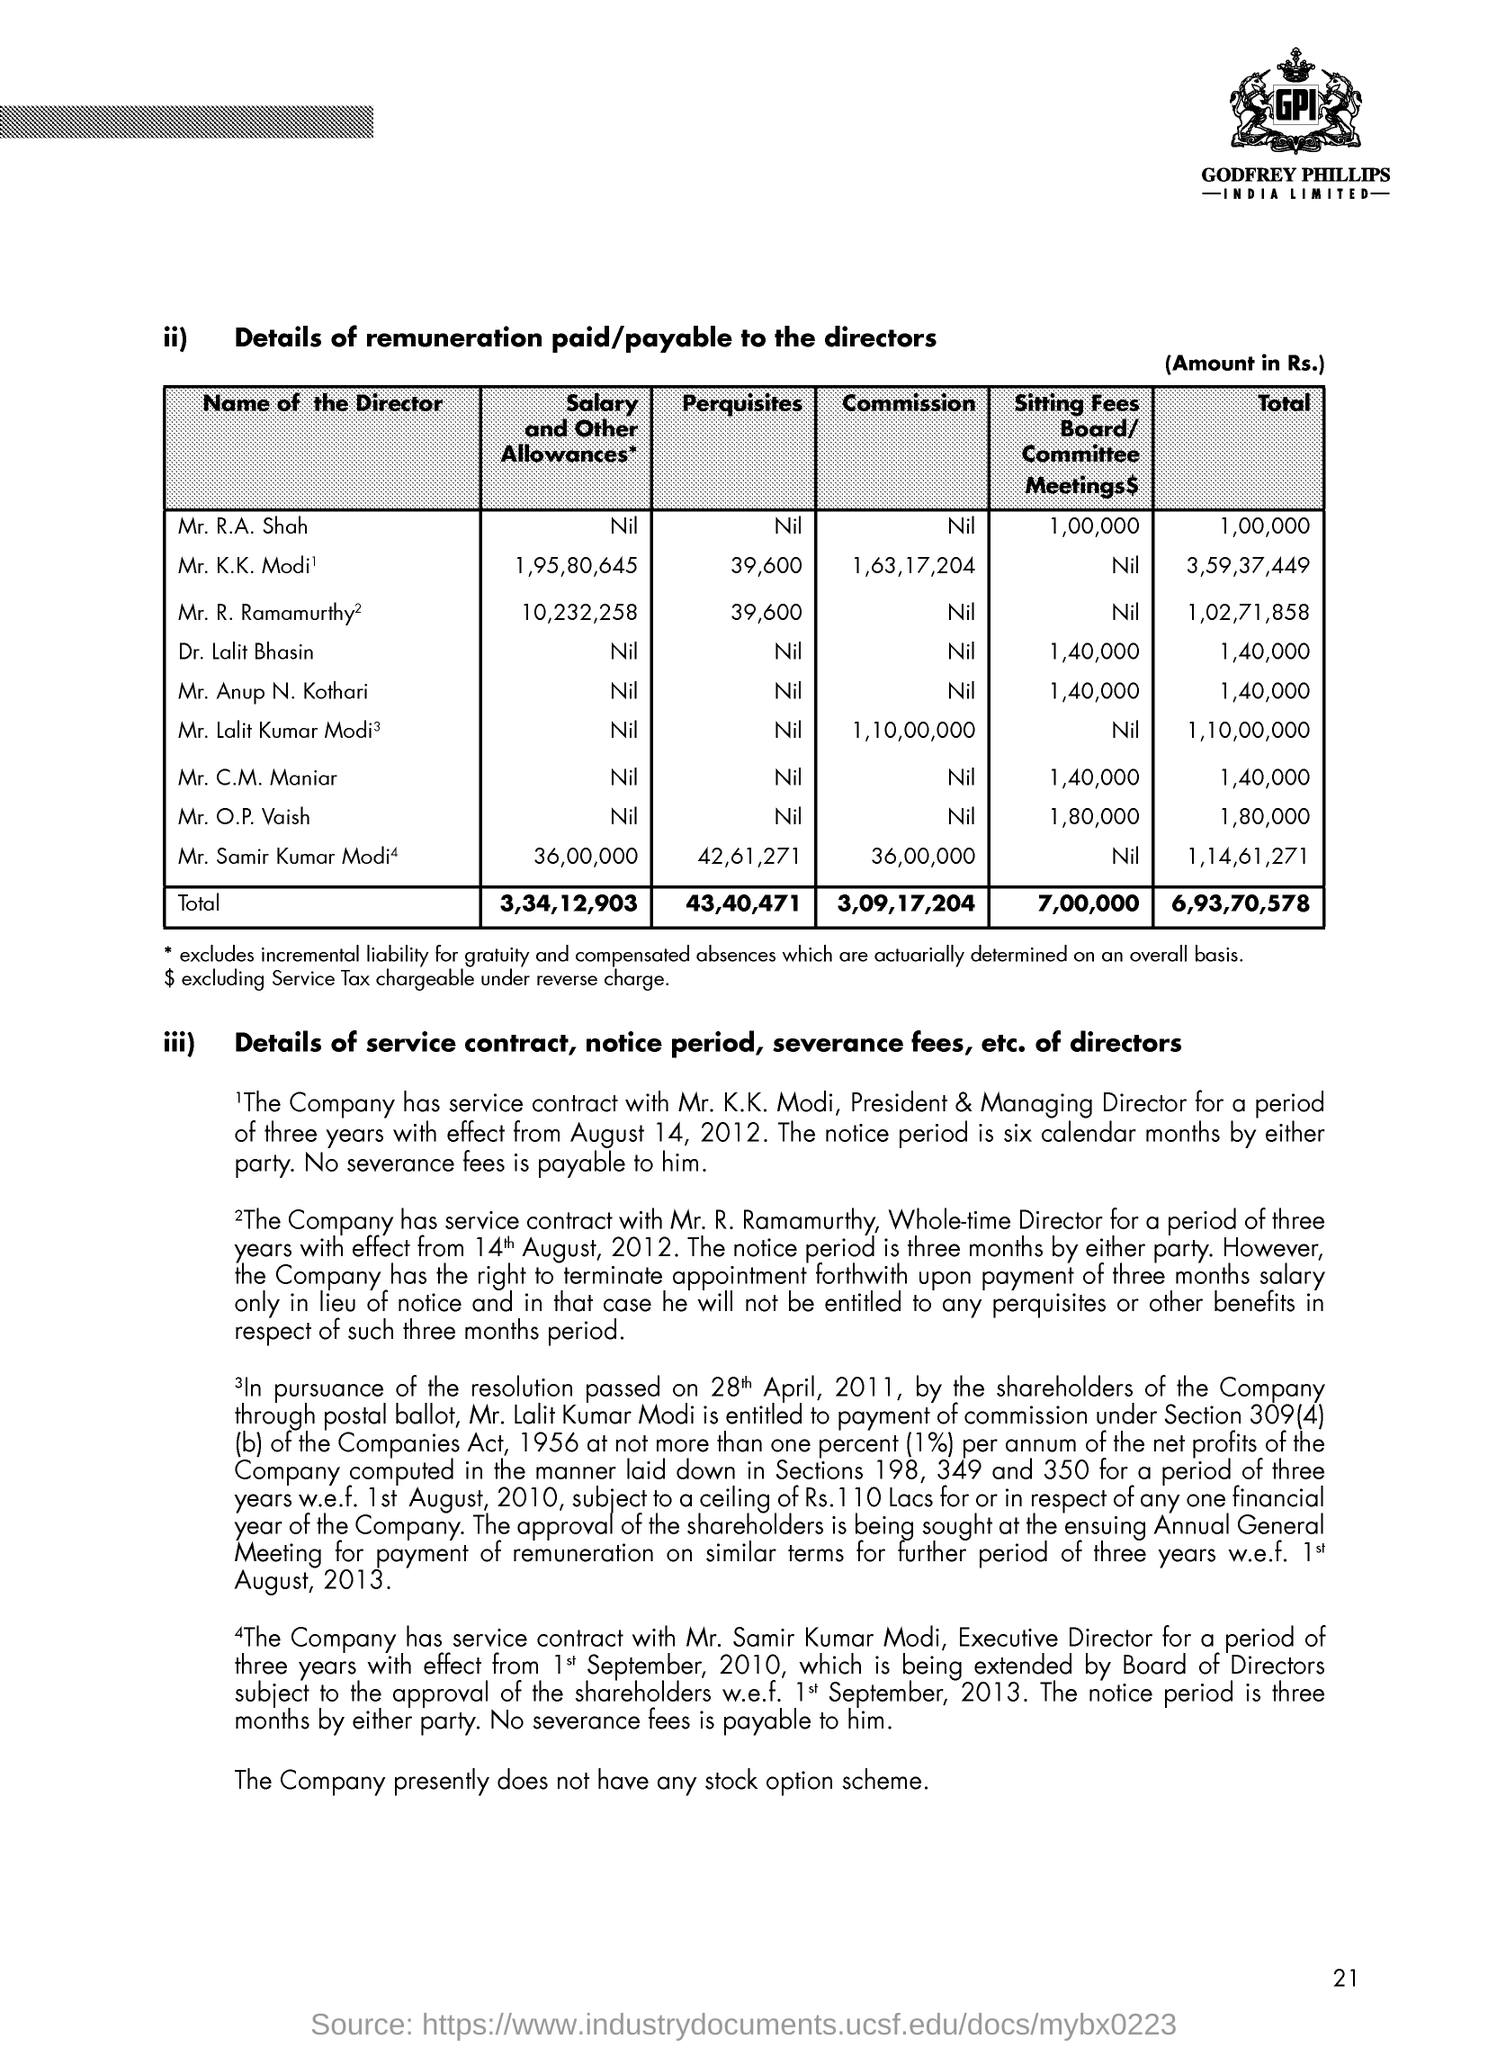List a handful of essential elements in this visual. The total remuneration paid to all directors is 6,93,70,578. The total amount of perquisites for all directors is 43,40,471. Mr. Samir Kumar Modi's salary and other allowances are 36,00,000. The total remuneration paid to Mr. R. A Shah is 1,00,000. The total remuneration paid to Mr. K.K Modi is 3,59,37,449. 